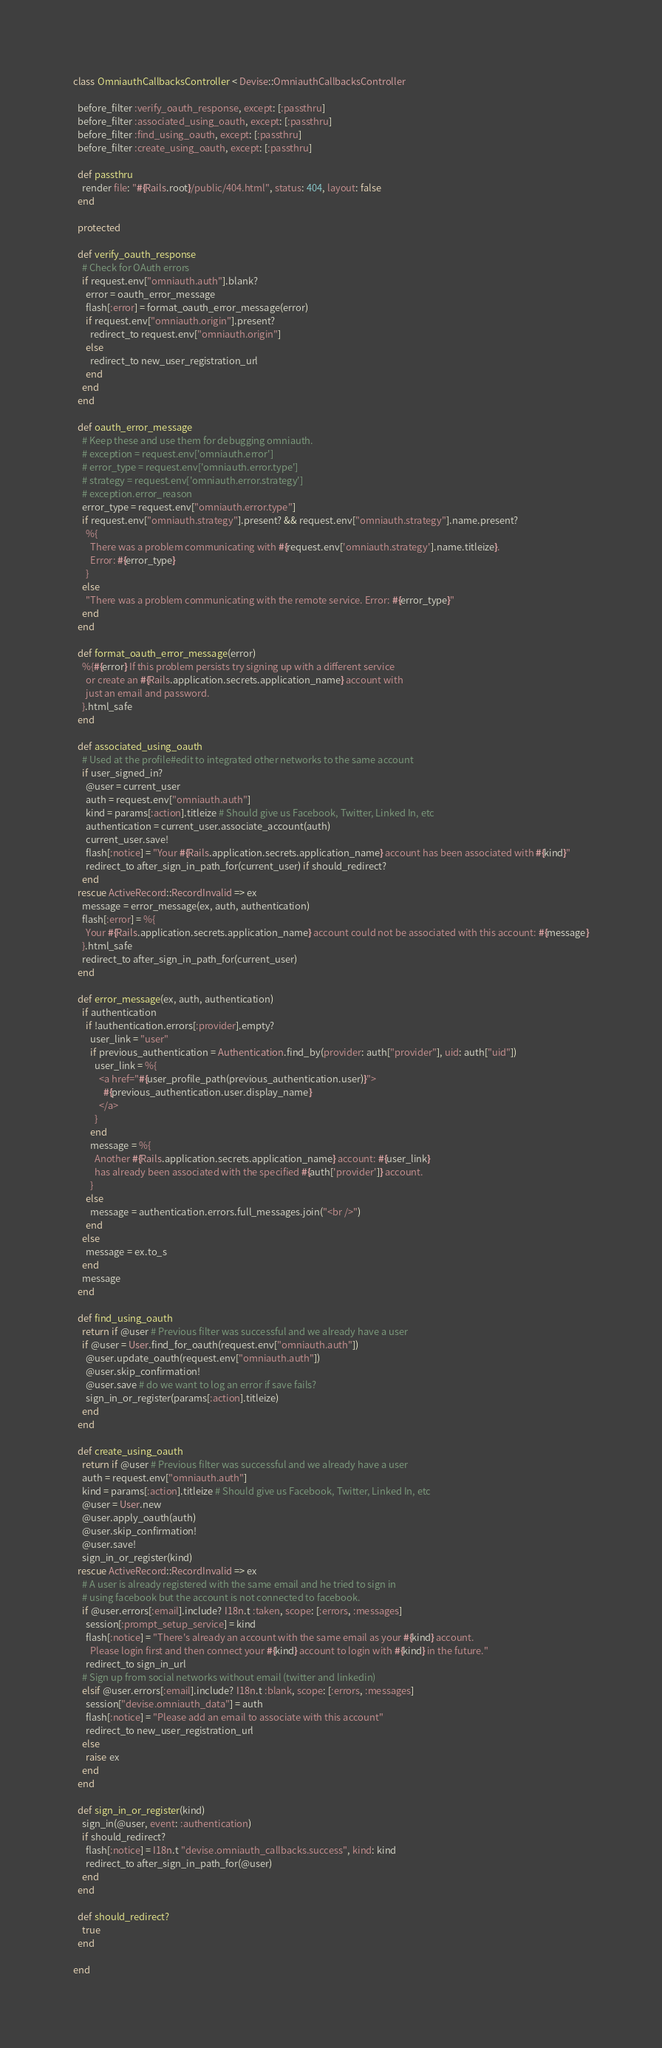<code> <loc_0><loc_0><loc_500><loc_500><_Ruby_>class OmniauthCallbacksController < Devise::OmniauthCallbacksController

  before_filter :verify_oauth_response, except: [:passthru]
  before_filter :associated_using_oauth, except: [:passthru]
  before_filter :find_using_oauth, except: [:passthru]
  before_filter :create_using_oauth, except: [:passthru]

  def passthru
    render file: "#{Rails.root}/public/404.html", status: 404, layout: false
  end

  protected

  def verify_oauth_response
    # Check for OAuth errors
    if request.env["omniauth.auth"].blank?
      error = oauth_error_message
      flash[:error] = format_oauth_error_message(error)
      if request.env["omniauth.origin"].present?
        redirect_to request.env["omniauth.origin"]
      else
        redirect_to new_user_registration_url
      end
    end
  end

  def oauth_error_message
    # Keep these and use them for debugging omniauth.
    # exception = request.env['omniauth.error']
    # error_type = request.env['omniauth.error.type']
    # strategy = request.env['omniauth.error.strategy']
    # exception.error_reason
    error_type = request.env["omniauth.error.type"]
    if request.env["omniauth.strategy"].present? && request.env["omniauth.strategy"].name.present?
      %{
        There was a problem communicating with #{request.env['omniauth.strategy'].name.titleize}.
        Error: #{error_type}
      }
    else
      "There was a problem communicating with the remote service. Error: #{error_type}"
    end
  end

  def format_oauth_error_message(error)
    %{#{error} If this problem persists try signing up with a different service
      or create an #{Rails.application.secrets.application_name} account with
      just an email and password.
    }.html_safe
  end

  def associated_using_oauth
    # Used at the profile#edit to integrated other networks to the same account
    if user_signed_in?
      @user = current_user
      auth = request.env["omniauth.auth"]
      kind = params[:action].titleize # Should give us Facebook, Twitter, Linked In, etc
      authentication = current_user.associate_account(auth)
      current_user.save!
      flash[:notice] = "Your #{Rails.application.secrets.application_name} account has been associated with #{kind}"
      redirect_to after_sign_in_path_for(current_user) if should_redirect?
    end
  rescue ActiveRecord::RecordInvalid => ex
    message = error_message(ex, auth, authentication)
    flash[:error] = %{
      Your #{Rails.application.secrets.application_name} account could not be associated with this account: #{message}
    }.html_safe
    redirect_to after_sign_in_path_for(current_user)
  end

  def error_message(ex, auth, authentication)
    if authentication
      if !authentication.errors[:provider].empty?
        user_link = "user"
        if previous_authentication = Authentication.find_by(provider: auth["provider"], uid: auth["uid"])
          user_link = %{
            <a href="#{user_profile_path(previous_authentication.user)}">
              #{previous_authentication.user.display_name}
            </a>
          }
        end
        message = %{
          Another #{Rails.application.secrets.application_name} account: #{user_link}
          has already been associated with the specified #{auth['provider']} account.
        }
      else
        message = authentication.errors.full_messages.join("<br />")
      end
    else
      message = ex.to_s
    end
    message
  end

  def find_using_oauth
    return if @user # Previous filter was successful and we already have a user
    if @user = User.find_for_oauth(request.env["omniauth.auth"])
      @user.update_oauth(request.env["omniauth.auth"])
      @user.skip_confirmation!
      @user.save # do we want to log an error if save fails?
      sign_in_or_register(params[:action].titleize)
    end
  end

  def create_using_oauth
    return if @user # Previous filter was successful and we already have a user
    auth = request.env["omniauth.auth"]
    kind = params[:action].titleize # Should give us Facebook, Twitter, Linked In, etc
    @user = User.new
    @user.apply_oauth(auth)
    @user.skip_confirmation!
    @user.save!
    sign_in_or_register(kind)
  rescue ActiveRecord::RecordInvalid => ex
    # A user is already registered with the same email and he tried to sign in
    # using facebook but the account is not connected to facebook.
    if @user.errors[:email].include? I18n.t :taken, scope: [:errors, :messages]
      session[:prompt_setup_service] = kind
      flash[:notice] = "There's already an account with the same email as your #{kind} account.
        Please login first and then connect your #{kind} account to login with #{kind} in the future."
      redirect_to sign_in_url
    # Sign up from social networks without email (twitter and linkedin)
    elsif @user.errors[:email].include? I18n.t :blank, scope: [:errors, :messages]
      session["devise.omniauth_data"] = auth
      flash[:notice] = "Please add an email to associate with this account"
      redirect_to new_user_registration_url
    else
      raise ex
    end
  end

  def sign_in_or_register(kind)
    sign_in(@user, event: :authentication)
    if should_redirect?
      flash[:notice] = I18n.t "devise.omniauth_callbacks.success", kind: kind
      redirect_to after_sign_in_path_for(@user)
    end
  end

  def should_redirect?
    true
  end

end
</code> 